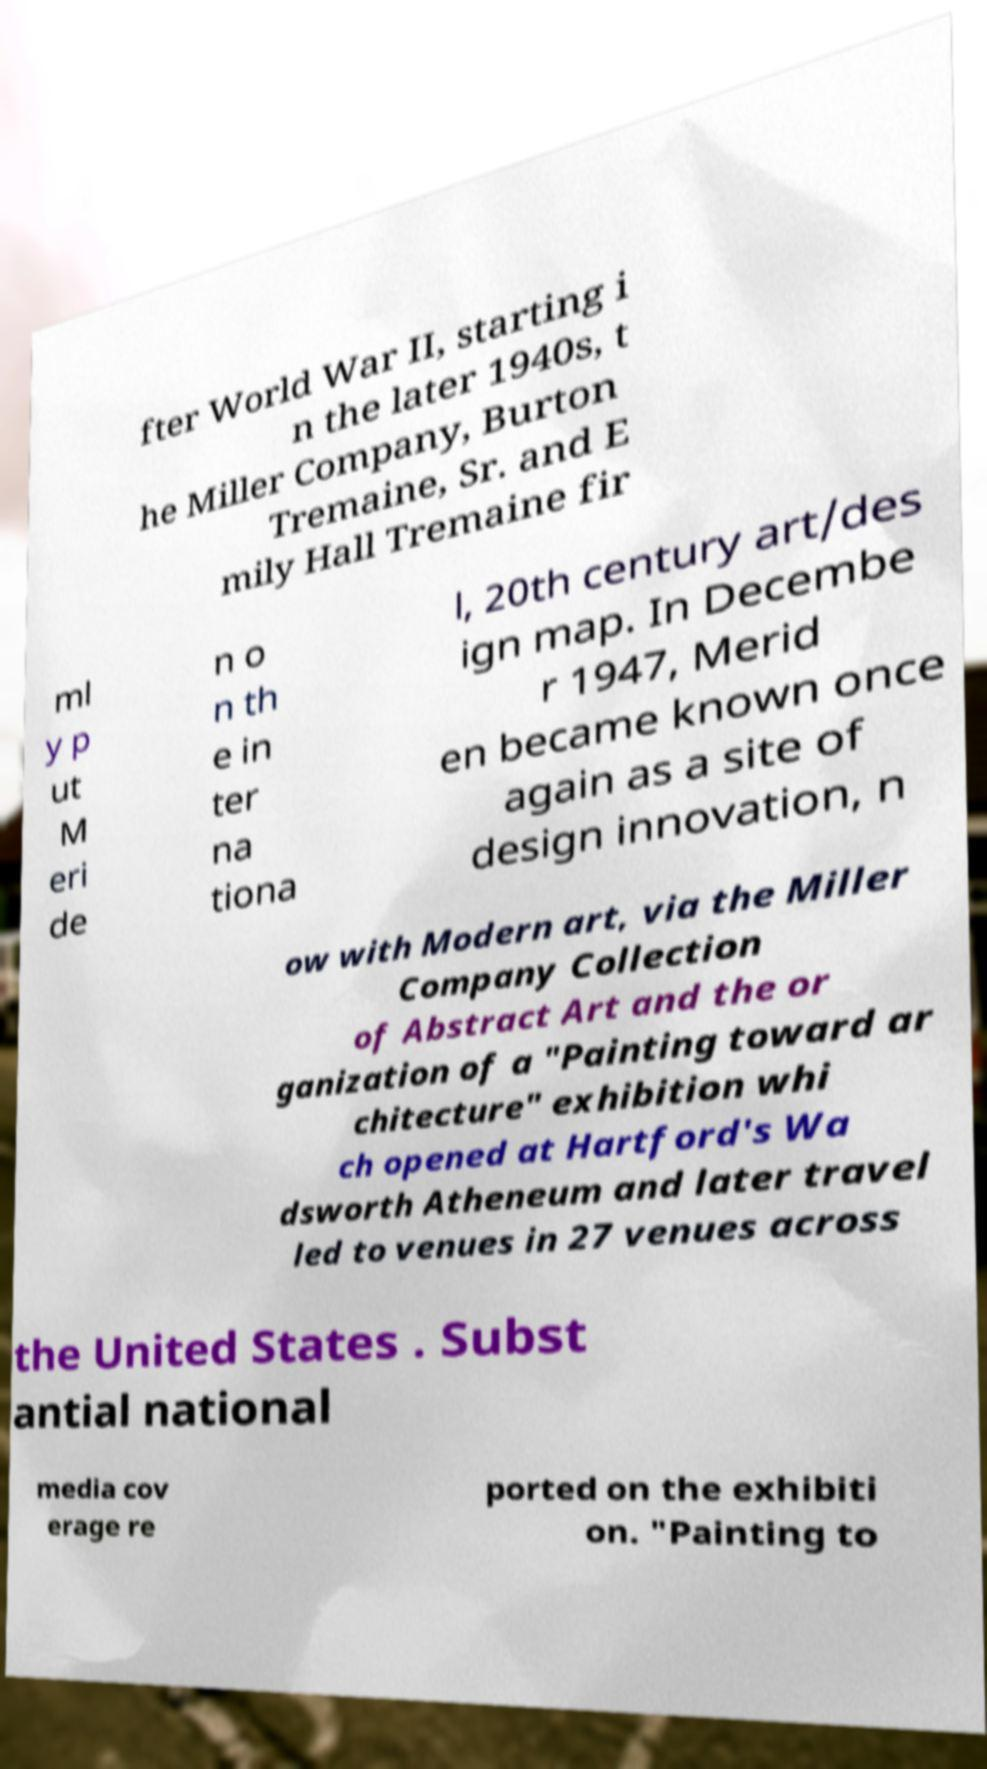I need the written content from this picture converted into text. Can you do that? fter World War II, starting i n the later 1940s, t he Miller Company, Burton Tremaine, Sr. and E mily Hall Tremaine fir ml y p ut M eri de n o n th e in ter na tiona l, 20th century art/des ign map. In Decembe r 1947, Merid en became known once again as a site of design innovation, n ow with Modern art, via the Miller Company Collection of Abstract Art and the or ganization of a "Painting toward ar chitecture" exhibition whi ch opened at Hartford's Wa dsworth Atheneum and later travel led to venues in 27 venues across the United States . Subst antial national media cov erage re ported on the exhibiti on. "Painting to 